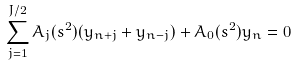Convert formula to latex. <formula><loc_0><loc_0><loc_500><loc_500>\sum _ { j = 1 } ^ { J / 2 } A _ { j } ( s ^ { 2 } ) ( y _ { n + j } + y _ { n - j } ) + A _ { 0 } ( s ^ { 2 } ) y _ { n } = 0</formula> 